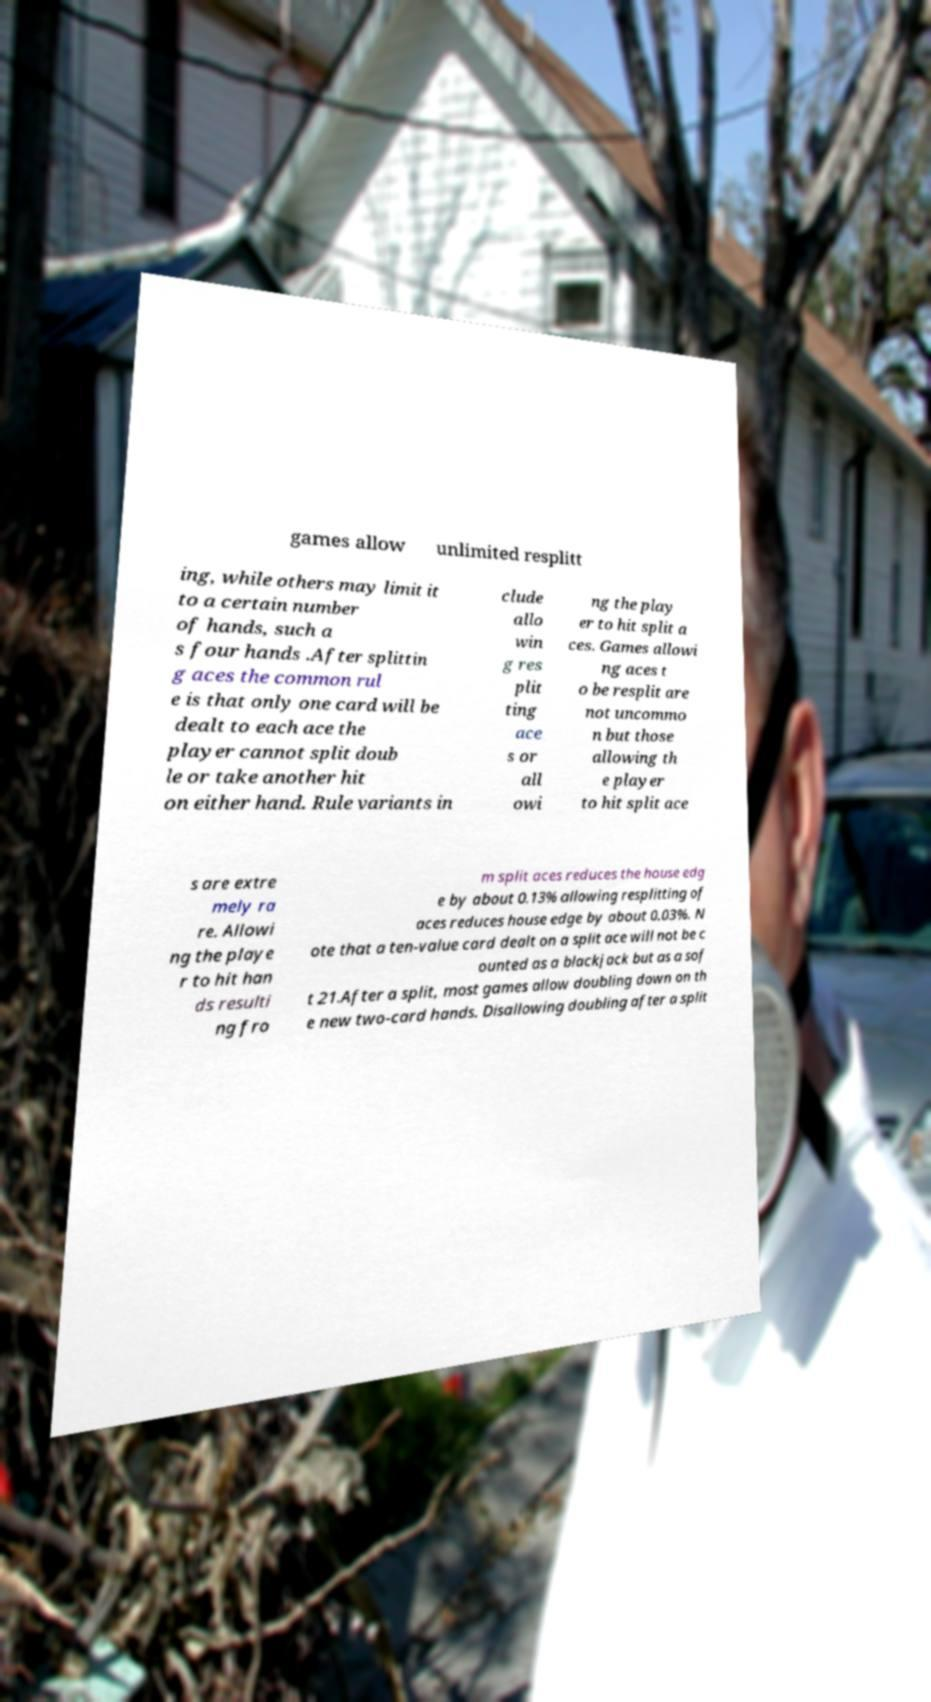Please read and relay the text visible in this image. What does it say? games allow unlimited resplitt ing, while others may limit it to a certain number of hands, such a s four hands .After splittin g aces the common rul e is that only one card will be dealt to each ace the player cannot split doub le or take another hit on either hand. Rule variants in clude allo win g res plit ting ace s or all owi ng the play er to hit split a ces. Games allowi ng aces t o be resplit are not uncommo n but those allowing th e player to hit split ace s are extre mely ra re. Allowi ng the playe r to hit han ds resulti ng fro m split aces reduces the house edg e by about 0.13% allowing resplitting of aces reduces house edge by about 0.03%. N ote that a ten-value card dealt on a split ace will not be c ounted as a blackjack but as a sof t 21.After a split, most games allow doubling down on th e new two-card hands. Disallowing doubling after a split 